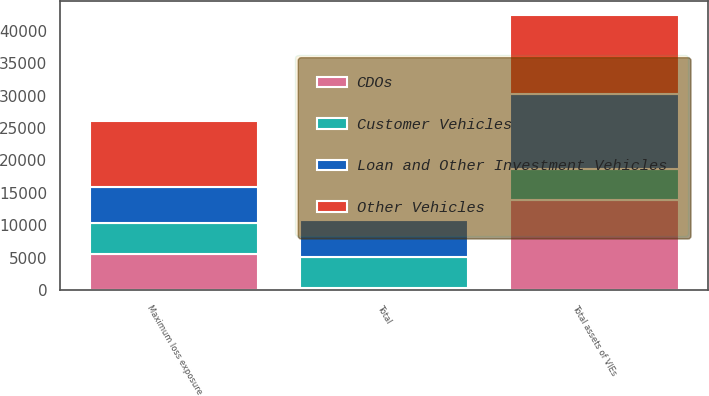<chart> <loc_0><loc_0><loc_500><loc_500><stacked_bar_chart><ecel><fcel>Maximum loss exposure<fcel>Total assets of VIEs<fcel>Total<nl><fcel>CDOs<fcel>5564<fcel>13893<fcel>378<nl><fcel>Loan and Other Investment Vehicles<fcel>5571<fcel>11507<fcel>5564<nl><fcel>Customer Vehicles<fcel>4812<fcel>4812<fcel>4812<nl><fcel>Other Vehicles<fcel>10143<fcel>12247<fcel>358<nl></chart> 